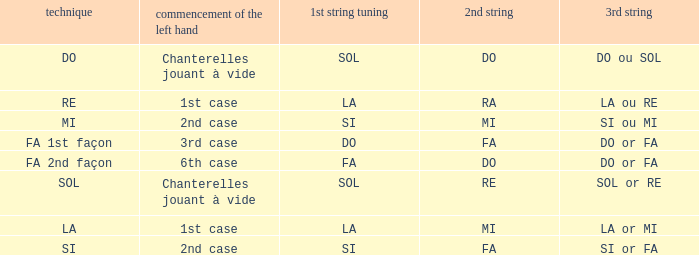Given that the 1st string is si accord du and the 2nd string is mi, what can be identified as the 3rd string? SI ou MI. 